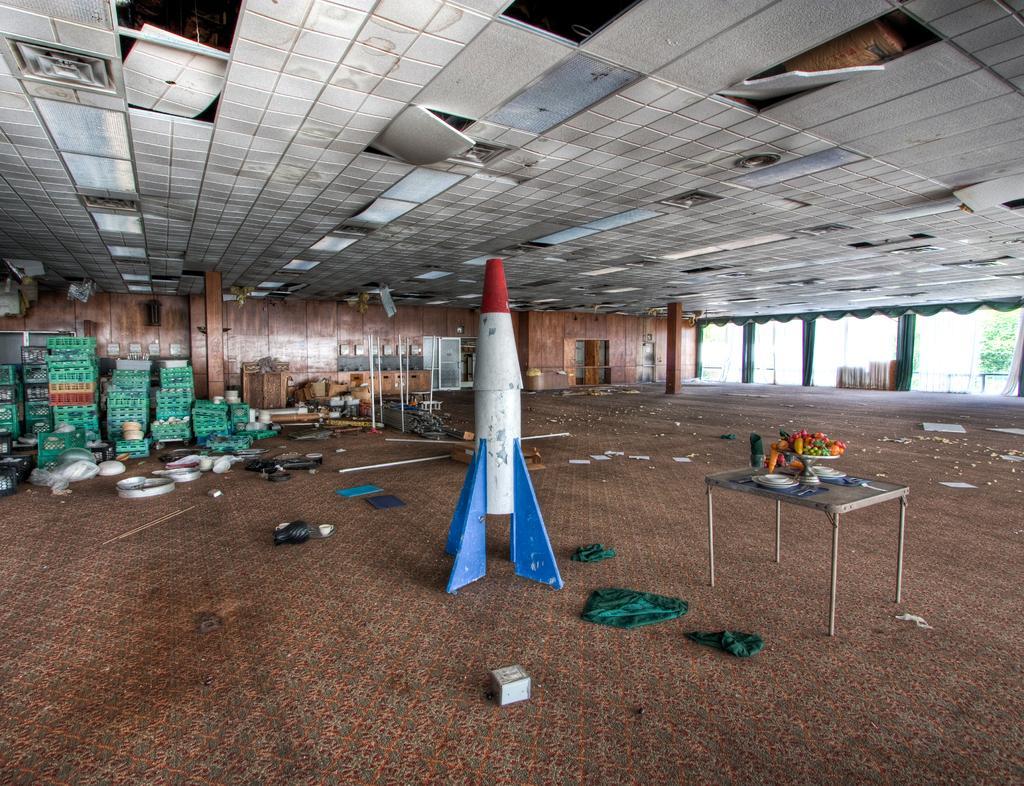In one or two sentences, can you explain what this image depicts? In this image see can see a table. On the table there are plates and a tray with some items. Also there is a model of a rocket. On the floor there are some items. In the back there are boxes and many other items. Also there are pillars. 